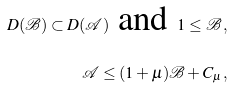<formula> <loc_0><loc_0><loc_500><loc_500>D ( { \mathcal { B } } ) \subset D ( { \mathcal { A } } ) \text { and } 1 \leq { \mathcal { B } } \, , \\ { \mathcal { A } } \leq ( 1 + \mu ) { \mathcal { B } } + C _ { \mu } \, ,</formula> 